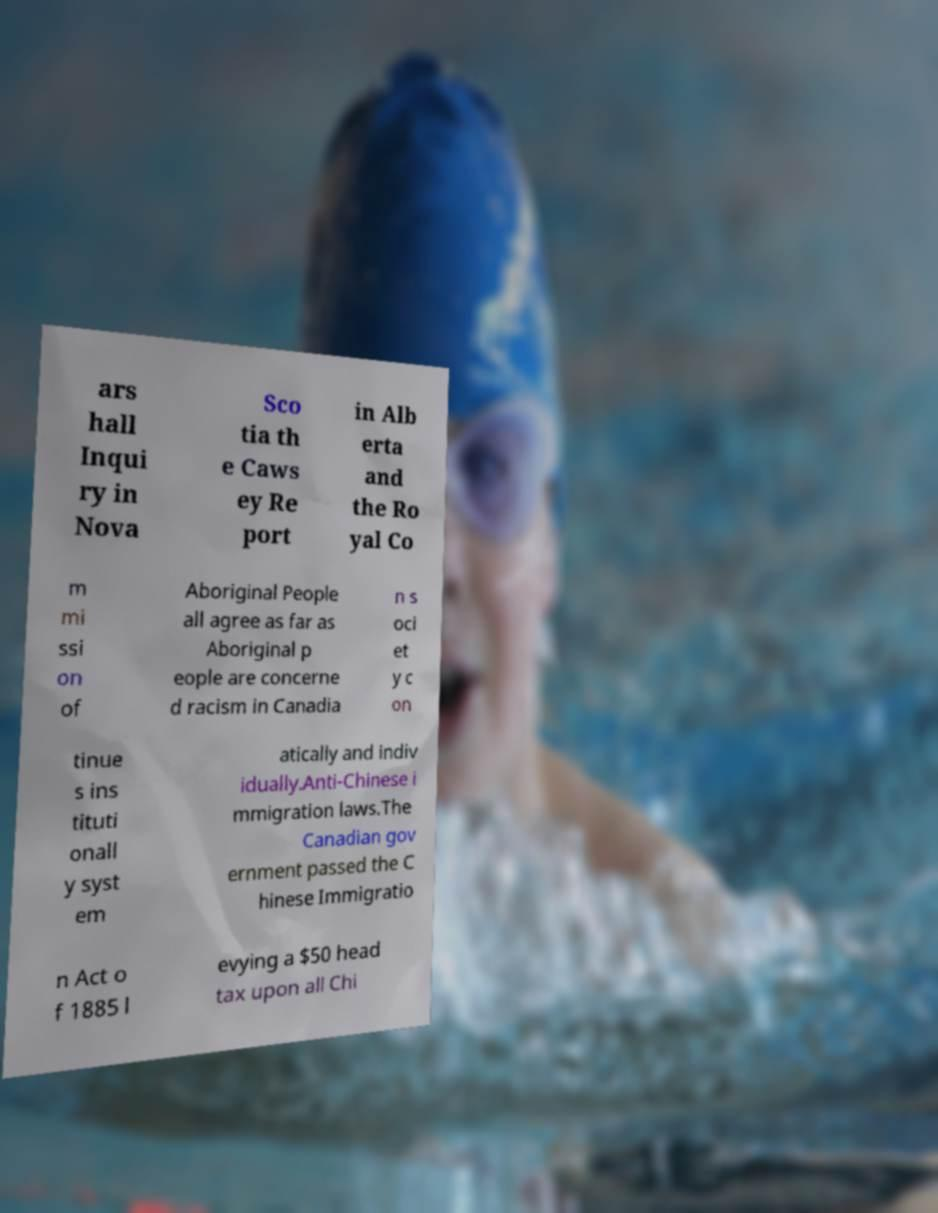Can you read and provide the text displayed in the image?This photo seems to have some interesting text. Can you extract and type it out for me? ars hall Inqui ry in Nova Sco tia th e Caws ey Re port in Alb erta and the Ro yal Co m mi ssi on of Aboriginal People all agree as far as Aboriginal p eople are concerne d racism in Canadia n s oci et y c on tinue s ins tituti onall y syst em atically and indiv idually.Anti-Chinese i mmigration laws.The Canadian gov ernment passed the C hinese Immigratio n Act o f 1885 l evying a $50 head tax upon all Chi 